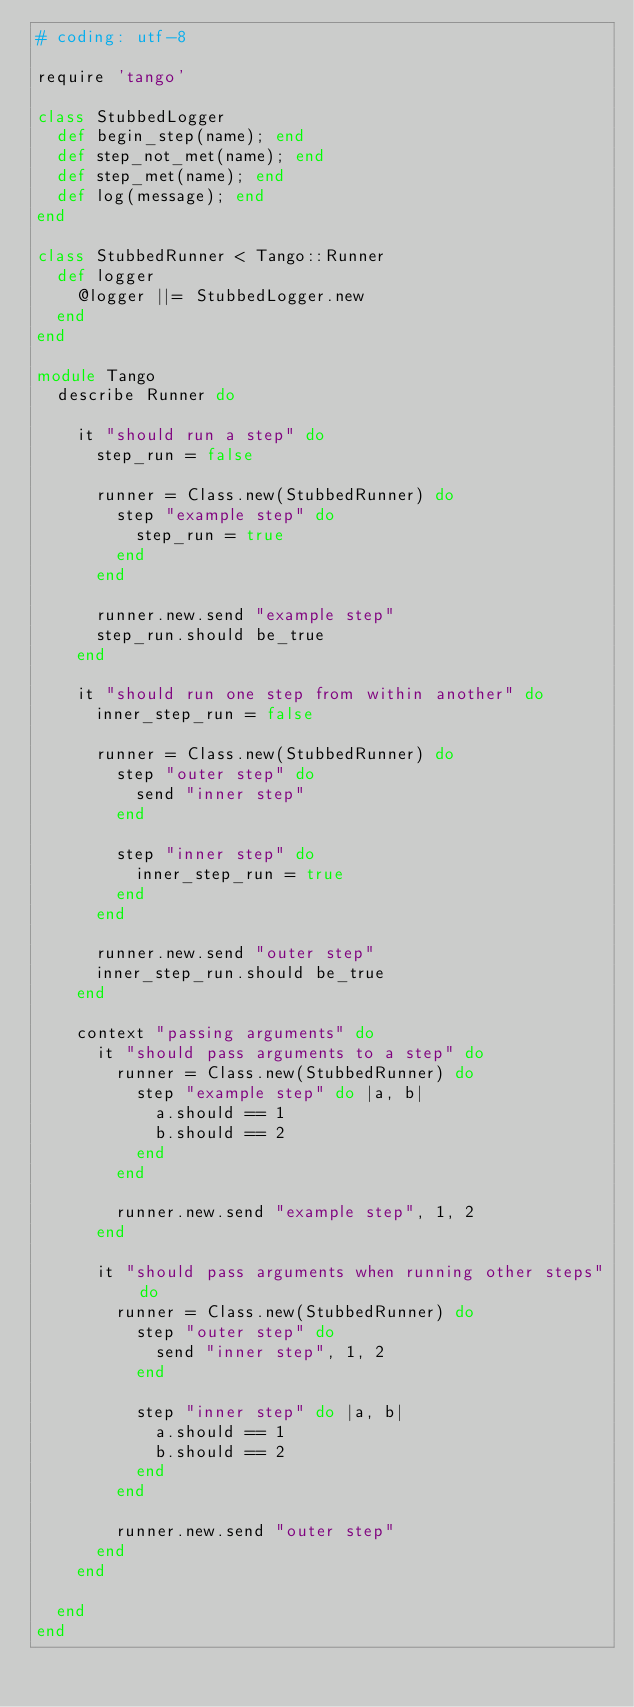Convert code to text. <code><loc_0><loc_0><loc_500><loc_500><_Ruby_># coding: utf-8

require 'tango'

class StubbedLogger
  def begin_step(name); end
  def step_not_met(name); end
  def step_met(name); end
  def log(message); end
end

class StubbedRunner < Tango::Runner
  def logger
    @logger ||= StubbedLogger.new
  end
end

module Tango
  describe Runner do

    it "should run a step" do
      step_run = false

      runner = Class.new(StubbedRunner) do
        step "example step" do
          step_run = true
        end
      end

      runner.new.send "example step"
      step_run.should be_true
    end

    it "should run one step from within another" do
      inner_step_run = false

      runner = Class.new(StubbedRunner) do
        step "outer step" do
          send "inner step"
        end

        step "inner step" do
          inner_step_run = true
        end
      end

      runner.new.send "outer step"
      inner_step_run.should be_true
    end

    context "passing arguments" do
      it "should pass arguments to a step" do
        runner = Class.new(StubbedRunner) do
          step "example step" do |a, b|
            a.should == 1
            b.should == 2
          end
        end

        runner.new.send "example step", 1, 2
      end

      it "should pass arguments when running other steps" do
        runner = Class.new(StubbedRunner) do
          step "outer step" do
            send "inner step", 1, 2
          end

          step "inner step" do |a, b|
            a.should == 1
            b.should == 2
          end
        end

        runner.new.send "outer step"
      end
    end

  end
end
</code> 